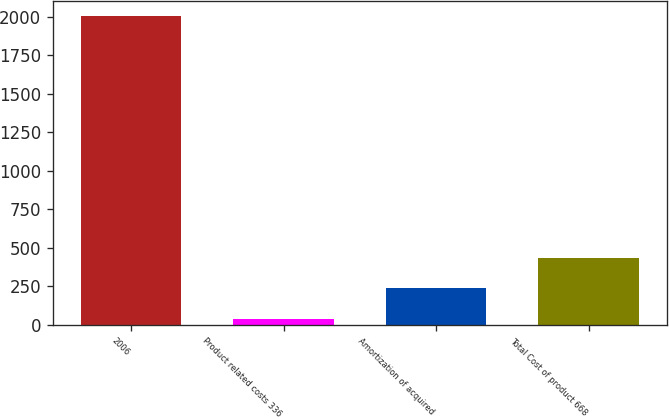Convert chart to OTSL. <chart><loc_0><loc_0><loc_500><loc_500><bar_chart><fcel>2006<fcel>Product related costs 336<fcel>Amortization of acquired<fcel>Total Cost of product 668<nl><fcel>2004<fcel>38<fcel>234.6<fcel>431.2<nl></chart> 